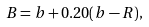Convert formula to latex. <formula><loc_0><loc_0><loc_500><loc_500>B = b + 0 . 2 0 ( b - R ) ,</formula> 